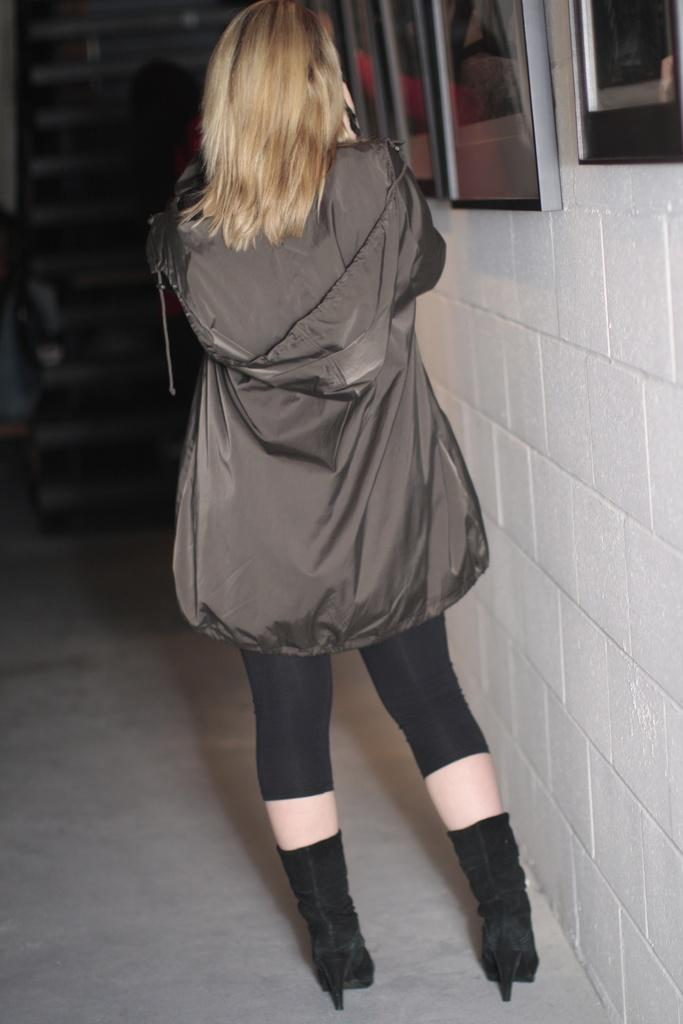What is the main subject in the foreground of the image? There is a woman in the foreground of the image. What is the woman wearing? The woman is wearing a grey coat. What is the woman's position in relation to the ground? The woman is standing on the ground. What can be seen in the background of the image? There is a wall and a window in the background of the image. How many springs can be seen in the image? There are no springs present in the image. What color are the woman's eyes in the image? The color of the woman's eyes cannot be determined from the image, as her eyes are not visible. 